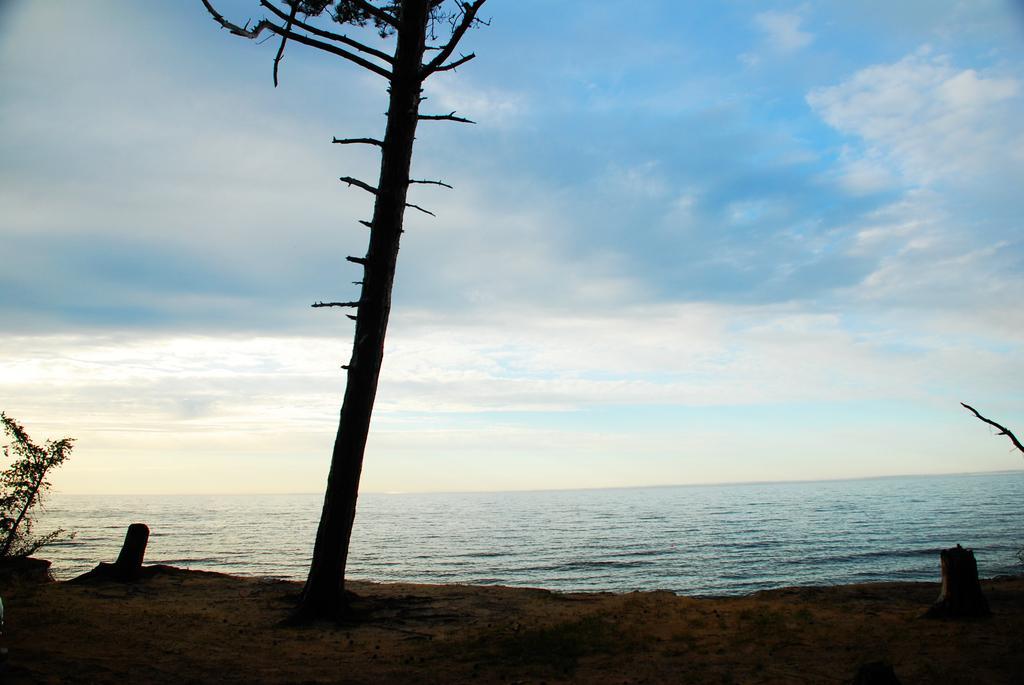How would you summarize this image in a sentence or two? In this picture we can see the ocean. In the center there is a big tree. On the left there is a plant on the beach. At the top we can see the sky and clouds. 